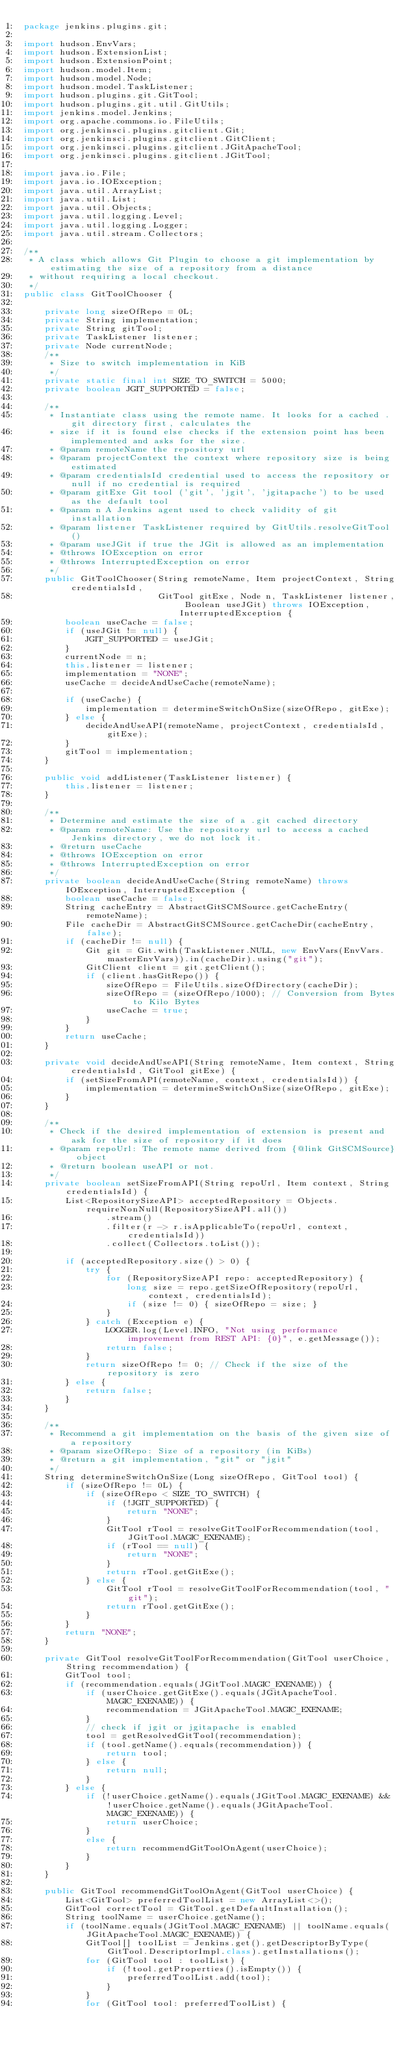Convert code to text. <code><loc_0><loc_0><loc_500><loc_500><_Java_>package jenkins.plugins.git;

import hudson.EnvVars;
import hudson.ExtensionList;
import hudson.ExtensionPoint;
import hudson.model.Item;
import hudson.model.Node;
import hudson.model.TaskListener;
import hudson.plugins.git.GitTool;
import hudson.plugins.git.util.GitUtils;
import jenkins.model.Jenkins;
import org.apache.commons.io.FileUtils;
import org.jenkinsci.plugins.gitclient.Git;
import org.jenkinsci.plugins.gitclient.GitClient;
import org.jenkinsci.plugins.gitclient.JGitApacheTool;
import org.jenkinsci.plugins.gitclient.JGitTool;

import java.io.File;
import java.io.IOException;
import java.util.ArrayList;
import java.util.List;
import java.util.Objects;
import java.util.logging.Level;
import java.util.logging.Logger;
import java.util.stream.Collectors;

/**
 * A class which allows Git Plugin to choose a git implementation by estimating the size of a repository from a distance
 * without requiring a local checkout.
 */
public class GitToolChooser {

    private long sizeOfRepo = 0L;
    private String implementation;
    private String gitTool;
    private TaskListener listener;
    private Node currentNode;
    /**
     * Size to switch implementation in KiB
     */
    private static final int SIZE_TO_SWITCH = 5000;
    private boolean JGIT_SUPPORTED = false;

    /**
     * Instantiate class using the remote name. It looks for a cached .git directory first, calculates the
     * size if it is found else checks if the extension point has been implemented and asks for the size.
     * @param remoteName the repository url
     * @param projectContext the context where repository size is being estimated
     * @param credentialsId credential used to access the repository or null if no credential is required
     * @param gitExe Git tool ('git', 'jgit', 'jgitapache') to be used as the default tool
     * @param n A Jenkins agent used to check validity of git installation
     * @param listener TaskListener required by GitUtils.resolveGitTool()
     * @param useJGit if true the JGit is allowed as an implementation
     * @throws IOException on error
     * @throws InterruptedException on error
     */
    public GitToolChooser(String remoteName, Item projectContext, String credentialsId,
                          GitTool gitExe, Node n, TaskListener listener, Boolean useJGit) throws IOException, InterruptedException {
        boolean useCache = false;
        if (useJGit != null) {
            JGIT_SUPPORTED = useJGit;
        }
        currentNode = n;
        this.listener = listener;
        implementation = "NONE";
        useCache = decideAndUseCache(remoteName);

        if (useCache) {
            implementation = determineSwitchOnSize(sizeOfRepo, gitExe);
        } else {
            decideAndUseAPI(remoteName, projectContext, credentialsId, gitExe);
        }
        gitTool = implementation;
    }

    public void addListener(TaskListener listener) {
        this.listener = listener;
    }

    /**
     * Determine and estimate the size of a .git cached directory
     * @param remoteName: Use the repository url to access a cached Jenkins directory, we do not lock it.
     * @return useCache
     * @throws IOException on error
     * @throws InterruptedException on error
     */
    private boolean decideAndUseCache(String remoteName) throws IOException, InterruptedException {
        boolean useCache = false;
        String cacheEntry = AbstractGitSCMSource.getCacheEntry(remoteName);
        File cacheDir = AbstractGitSCMSource.getCacheDir(cacheEntry, false);
        if (cacheDir != null) {
            Git git = Git.with(TaskListener.NULL, new EnvVars(EnvVars.masterEnvVars)).in(cacheDir).using("git");
            GitClient client = git.getClient();
            if (client.hasGitRepo()) {
                sizeOfRepo = FileUtils.sizeOfDirectory(cacheDir);
                sizeOfRepo = (sizeOfRepo/1000); // Conversion from Bytes to Kilo Bytes
                useCache = true;
            }
        }
        return useCache;
    }

    private void decideAndUseAPI(String remoteName, Item context, String credentialsId, GitTool gitExe) {
        if (setSizeFromAPI(remoteName, context, credentialsId)) {
            implementation = determineSwitchOnSize(sizeOfRepo, gitExe);
        }
    }

    /**
     * Check if the desired implementation of extension is present and ask for the size of repository if it does
     * @param repoUrl: The remote name derived from {@link GitSCMSource} object
     * @return boolean useAPI or not.
     */
    private boolean setSizeFromAPI(String repoUrl, Item context, String credentialsId) {
        List<RepositorySizeAPI> acceptedRepository = Objects.requireNonNull(RepositorySizeAPI.all())
                .stream()
                .filter(r -> r.isApplicableTo(repoUrl, context, credentialsId))
                .collect(Collectors.toList());

        if (acceptedRepository.size() > 0) {
            try {
                for (RepositorySizeAPI repo: acceptedRepository) {
                    long size = repo.getSizeOfRepository(repoUrl, context, credentialsId);
                    if (size != 0) { sizeOfRepo = size; }
                }
            } catch (Exception e) {
                LOGGER.log(Level.INFO, "Not using performance improvement from REST API: {0}", e.getMessage());
                return false;
            }
            return sizeOfRepo != 0; // Check if the size of the repository is zero
        } else {
            return false;
        }
    }

    /**
     * Recommend a git implementation on the basis of the given size of a repository
     * @param sizeOfRepo: Size of a repository (in KiBs)
     * @return a git implementation, "git" or "jgit"
     */
    String determineSwitchOnSize(Long sizeOfRepo, GitTool tool) {
        if (sizeOfRepo != 0L) {
            if (sizeOfRepo < SIZE_TO_SWITCH) {
                if (!JGIT_SUPPORTED) {
                    return "NONE";
                }
                GitTool rTool = resolveGitToolForRecommendation(tool, JGitTool.MAGIC_EXENAME);
                if (rTool == null) {
                    return "NONE";
                }
                return rTool.getGitExe();
            } else {
                GitTool rTool = resolveGitToolForRecommendation(tool, "git");
                return rTool.getGitExe();
            }
        }
        return "NONE";
    }

    private GitTool resolveGitToolForRecommendation(GitTool userChoice, String recommendation) {
        GitTool tool;
        if (recommendation.equals(JGitTool.MAGIC_EXENAME)) {
            if (userChoice.getGitExe().equals(JGitApacheTool.MAGIC_EXENAME)) {
                recommendation = JGitApacheTool.MAGIC_EXENAME;
            }
            // check if jgit or jgitapache is enabled
            tool = getResolvedGitTool(recommendation);
            if (tool.getName().equals(recommendation)) {
                return tool;
            } else {
                return null;
            }
        } else {
            if (!userChoice.getName().equals(JGitTool.MAGIC_EXENAME) && !userChoice.getName().equals(JGitApacheTool.MAGIC_EXENAME)) {
                return userChoice;
            }
            else {
                return recommendGitToolOnAgent(userChoice);
            }
        }
    }

    public GitTool recommendGitToolOnAgent(GitTool userChoice) {
        List<GitTool> preferredToolList = new ArrayList<>();
        GitTool correctTool = GitTool.getDefaultInstallation();
        String toolName = userChoice.getName();
        if (toolName.equals(JGitTool.MAGIC_EXENAME) || toolName.equals(JGitApacheTool.MAGIC_EXENAME)) {
            GitTool[] toolList = Jenkins.get().getDescriptorByType(GitTool.DescriptorImpl.class).getInstallations();
            for (GitTool tool : toolList) {
                if (!tool.getProperties().isEmpty()) {
                    preferredToolList.add(tool);
                }
            }
            for (GitTool tool: preferredToolList) {</code> 